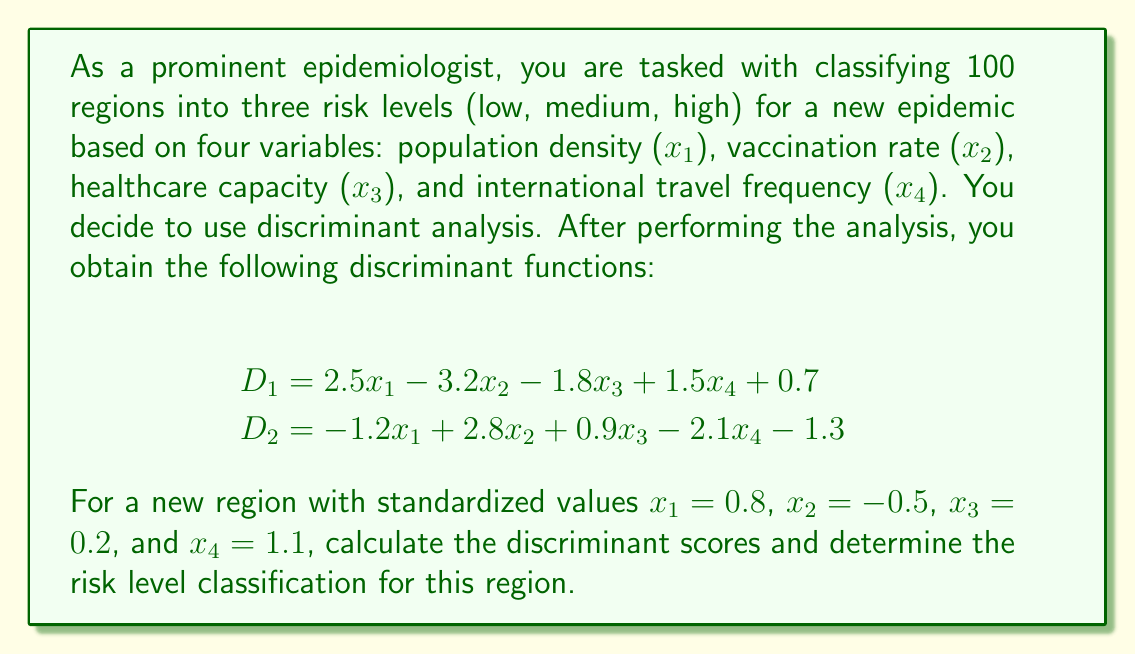What is the answer to this math problem? To solve this problem, we need to follow these steps:

1) Calculate the discriminant scores $D_1$ and $D_2$ using the given functions and the standardized values for the new region.

2) Interpret the scores to classify the region into one of the three risk levels.

Step 1: Calculating discriminant scores

For $D_1$:
$$\begin{align}
D_1 &= 2.5x_1 - 3.2x_2 - 1.8x_3 + 1.5x_4 + 0.7 \\
&= 2.5(0.8) - 3.2(-0.5) - 1.8(0.2) + 1.5(1.1) + 0.7 \\
&= 2.0 + 1.6 - 0.36 + 1.65 + 0.7 \\
&= 5.59
\end{align}$$

For $D_2$:
$$\begin{align}
D_2 &= -1.2x_1 + 2.8x_2 + 0.9x_3 - 2.1x_4 - 1.3 \\
&= -1.2(0.8) + 2.8(-0.5) + 0.9(0.2) - 2.1(1.1) - 1.3 \\
&= -0.96 - 1.4 + 0.18 - 2.31 - 1.3 \\
&= -5.79
\end{align}$$

Step 2: Interpreting the scores

In discriminant analysis with three groups, we typically interpret the scores as follows:

- If $D_1 > 0$ and $D_2 > 0$, classify as high risk
- If $D_1 > 0$ and $D_2 < 0$, classify as medium risk
- If $D_1 < 0$, classify as low risk

In this case, we have $D_1 = 5.59 > 0$ and $D_2 = -5.79 < 0$.
Answer: The discriminant scores are $D_1 = 5.59$ and $D_2 = -5.79$. Since $D_1 > 0$ and $D_2 < 0$, the new region is classified as medium risk for the epidemic. 